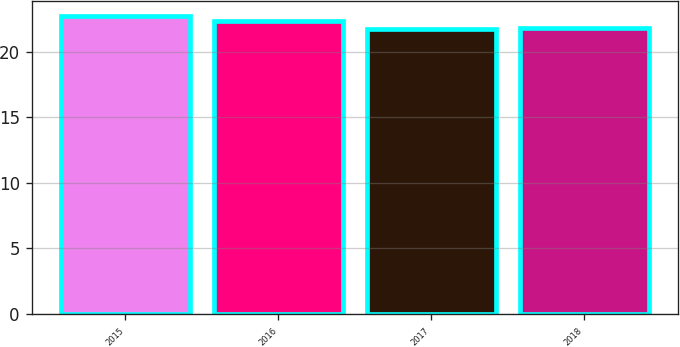<chart> <loc_0><loc_0><loc_500><loc_500><bar_chart><fcel>2015<fcel>2016<fcel>2017<fcel>2018<nl><fcel>22.7<fcel>22.3<fcel>21.7<fcel>21.8<nl></chart> 